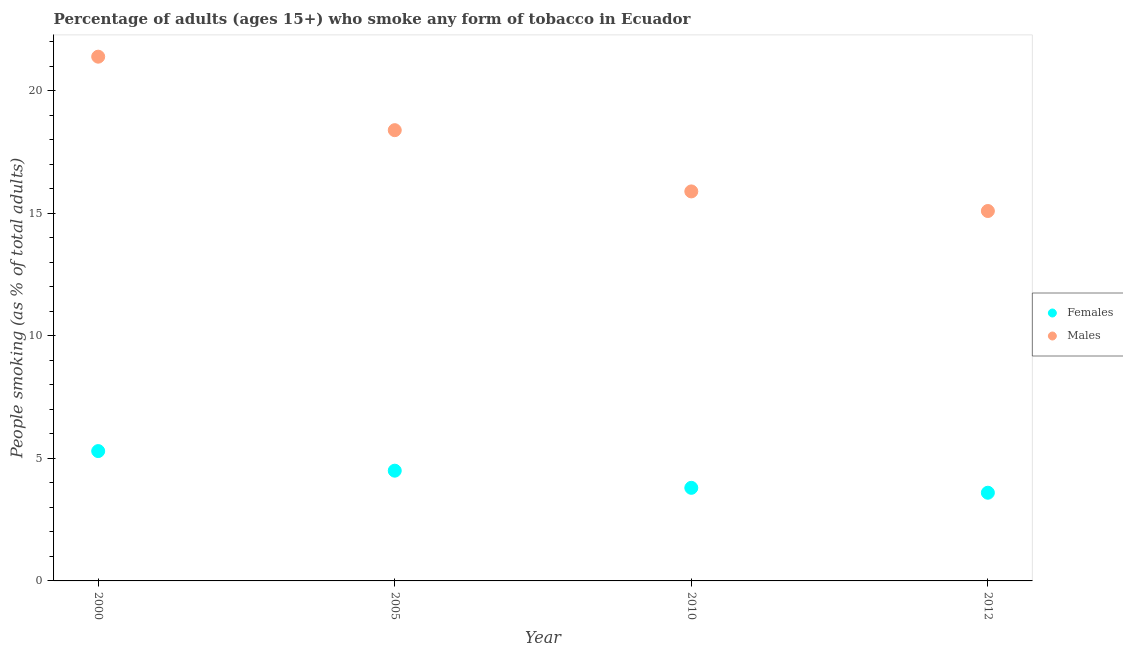Is the number of dotlines equal to the number of legend labels?
Offer a very short reply. Yes. What is the percentage of males who smoke in 2012?
Provide a succinct answer. 15.1. In which year was the percentage of males who smoke maximum?
Keep it short and to the point. 2000. What is the total percentage of females who smoke in the graph?
Provide a short and direct response. 17.2. What is the difference between the percentage of males who smoke in 2000 and that in 2005?
Keep it short and to the point. 3. What is the difference between the percentage of females who smoke in 2010 and the percentage of males who smoke in 2005?
Provide a short and direct response. -14.6. In the year 2010, what is the difference between the percentage of females who smoke and percentage of males who smoke?
Your answer should be very brief. -12.1. In how many years, is the percentage of females who smoke greater than 5 %?
Provide a succinct answer. 1. What is the ratio of the percentage of females who smoke in 2005 to that in 2010?
Provide a short and direct response. 1.18. Is the percentage of males who smoke in 2000 less than that in 2010?
Keep it short and to the point. No. What is the difference between the highest and the second highest percentage of females who smoke?
Your answer should be very brief. 0.8. What is the difference between the highest and the lowest percentage of females who smoke?
Provide a short and direct response. 1.7. Is the sum of the percentage of females who smoke in 2000 and 2005 greater than the maximum percentage of males who smoke across all years?
Keep it short and to the point. No. How many years are there in the graph?
Keep it short and to the point. 4. Are the values on the major ticks of Y-axis written in scientific E-notation?
Provide a short and direct response. No. Where does the legend appear in the graph?
Ensure brevity in your answer.  Center right. What is the title of the graph?
Your response must be concise. Percentage of adults (ages 15+) who smoke any form of tobacco in Ecuador. Does "2012 US$" appear as one of the legend labels in the graph?
Give a very brief answer. No. What is the label or title of the X-axis?
Ensure brevity in your answer.  Year. What is the label or title of the Y-axis?
Offer a terse response. People smoking (as % of total adults). What is the People smoking (as % of total adults) of Females in 2000?
Keep it short and to the point. 5.3. What is the People smoking (as % of total adults) in Males in 2000?
Provide a succinct answer. 21.4. What is the People smoking (as % of total adults) in Females in 2005?
Make the answer very short. 4.5. What is the People smoking (as % of total adults) of Males in 2005?
Offer a terse response. 18.4. What is the People smoking (as % of total adults) of Females in 2010?
Provide a succinct answer. 3.8. What is the People smoking (as % of total adults) in Females in 2012?
Ensure brevity in your answer.  3.6. Across all years, what is the maximum People smoking (as % of total adults) of Females?
Offer a very short reply. 5.3. Across all years, what is the maximum People smoking (as % of total adults) of Males?
Provide a succinct answer. 21.4. Across all years, what is the minimum People smoking (as % of total adults) of Males?
Your answer should be compact. 15.1. What is the total People smoking (as % of total adults) of Females in the graph?
Keep it short and to the point. 17.2. What is the total People smoking (as % of total adults) in Males in the graph?
Your answer should be compact. 70.8. What is the difference between the People smoking (as % of total adults) in Females in 2000 and that in 2005?
Provide a succinct answer. 0.8. What is the difference between the People smoking (as % of total adults) in Males in 2000 and that in 2005?
Give a very brief answer. 3. What is the difference between the People smoking (as % of total adults) in Females in 2000 and that in 2010?
Ensure brevity in your answer.  1.5. What is the difference between the People smoking (as % of total adults) of Males in 2000 and that in 2010?
Provide a succinct answer. 5.5. What is the difference between the People smoking (as % of total adults) of Males in 2005 and that in 2010?
Offer a terse response. 2.5. What is the difference between the People smoking (as % of total adults) in Females in 2005 and that in 2012?
Your response must be concise. 0.9. What is the difference between the People smoking (as % of total adults) in Females in 2010 and that in 2012?
Provide a succinct answer. 0.2. What is the difference between the People smoking (as % of total adults) of Females in 2000 and the People smoking (as % of total adults) of Males in 2005?
Keep it short and to the point. -13.1. What is the difference between the People smoking (as % of total adults) in Females in 2000 and the People smoking (as % of total adults) in Males in 2010?
Your answer should be very brief. -10.6. What is the difference between the People smoking (as % of total adults) in Females in 2000 and the People smoking (as % of total adults) in Males in 2012?
Provide a succinct answer. -9.8. What is the difference between the People smoking (as % of total adults) in Females in 2005 and the People smoking (as % of total adults) in Males in 2010?
Provide a short and direct response. -11.4. What is the difference between the People smoking (as % of total adults) in Females in 2005 and the People smoking (as % of total adults) in Males in 2012?
Ensure brevity in your answer.  -10.6. What is the difference between the People smoking (as % of total adults) of Females in 2010 and the People smoking (as % of total adults) of Males in 2012?
Offer a very short reply. -11.3. What is the average People smoking (as % of total adults) of Females per year?
Make the answer very short. 4.3. In the year 2000, what is the difference between the People smoking (as % of total adults) in Females and People smoking (as % of total adults) in Males?
Your answer should be compact. -16.1. What is the ratio of the People smoking (as % of total adults) of Females in 2000 to that in 2005?
Your answer should be very brief. 1.18. What is the ratio of the People smoking (as % of total adults) of Males in 2000 to that in 2005?
Make the answer very short. 1.16. What is the ratio of the People smoking (as % of total adults) in Females in 2000 to that in 2010?
Your response must be concise. 1.39. What is the ratio of the People smoking (as % of total adults) of Males in 2000 to that in 2010?
Your response must be concise. 1.35. What is the ratio of the People smoking (as % of total adults) of Females in 2000 to that in 2012?
Keep it short and to the point. 1.47. What is the ratio of the People smoking (as % of total adults) of Males in 2000 to that in 2012?
Offer a very short reply. 1.42. What is the ratio of the People smoking (as % of total adults) of Females in 2005 to that in 2010?
Provide a short and direct response. 1.18. What is the ratio of the People smoking (as % of total adults) in Males in 2005 to that in 2010?
Your response must be concise. 1.16. What is the ratio of the People smoking (as % of total adults) in Females in 2005 to that in 2012?
Provide a succinct answer. 1.25. What is the ratio of the People smoking (as % of total adults) of Males in 2005 to that in 2012?
Offer a very short reply. 1.22. What is the ratio of the People smoking (as % of total adults) in Females in 2010 to that in 2012?
Ensure brevity in your answer.  1.06. What is the ratio of the People smoking (as % of total adults) of Males in 2010 to that in 2012?
Offer a very short reply. 1.05. What is the difference between the highest and the second highest People smoking (as % of total adults) of Females?
Your answer should be compact. 0.8. What is the difference between the highest and the second highest People smoking (as % of total adults) in Males?
Give a very brief answer. 3. What is the difference between the highest and the lowest People smoking (as % of total adults) of Males?
Provide a short and direct response. 6.3. 